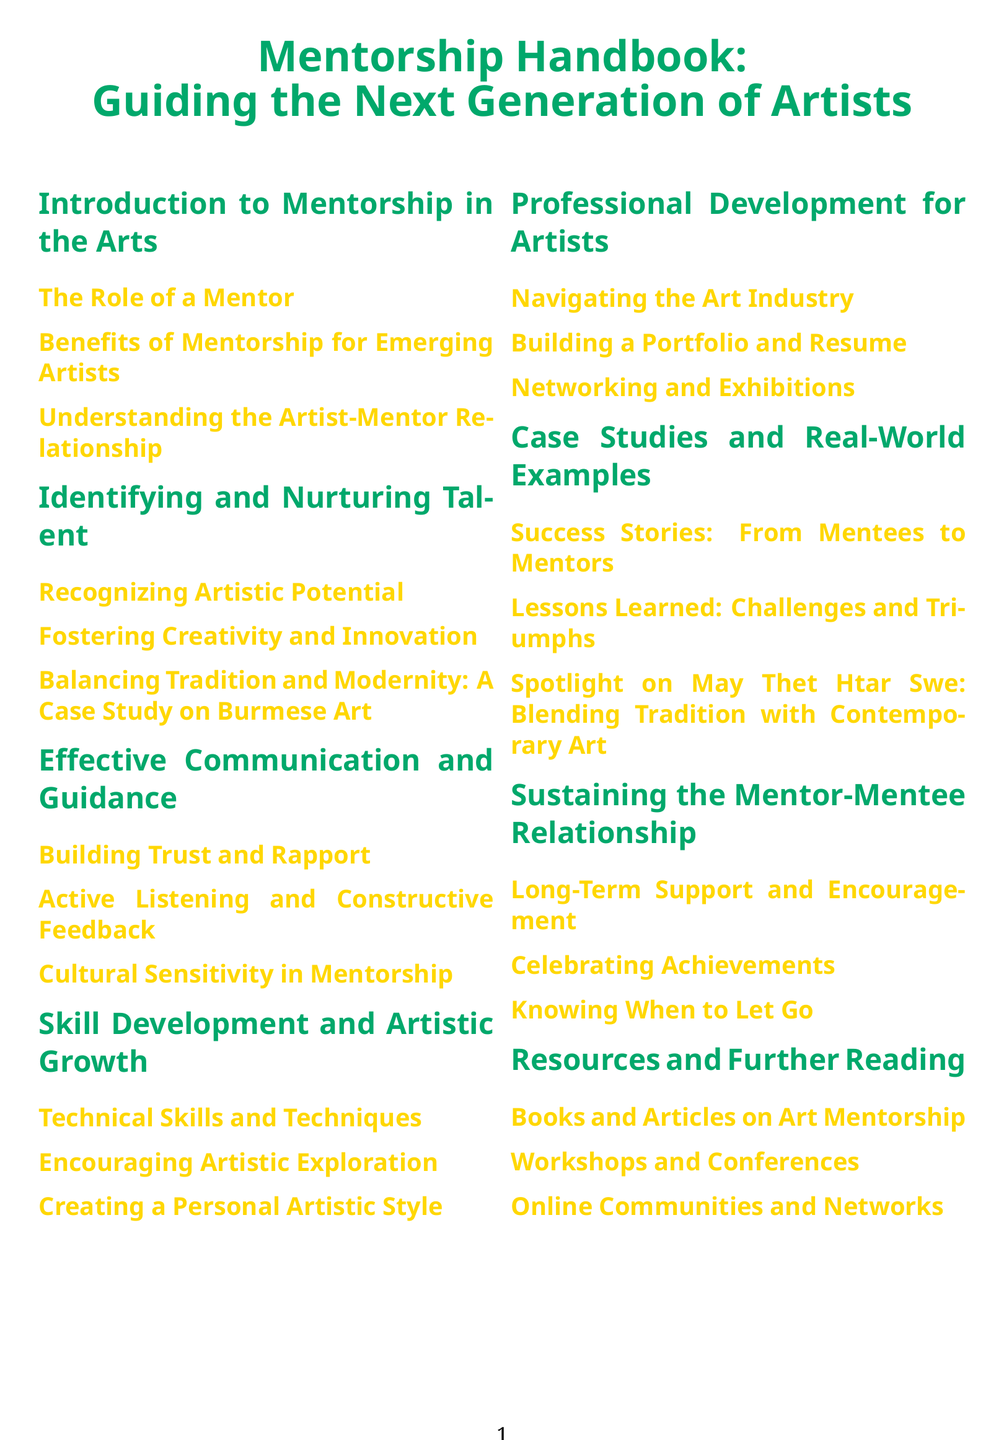what is the title of the handbook? The title of the handbook is the main heading found at the top of the document.
Answer: Mentorship Handbook: Guiding the Next Generation of Artists how many sections are in the document? The total number of sections has to be counted from the table of contents listed in the document.
Answer: 8 what is one of the case studies mentioned in the handbook? The specific case study is referenced in the section about case studies and real-world examples.
Answer: Spotlight on May Thet Htar Swe: Blending Tradition with Contemporary Art name a benefit of mentorship for emerging artists. This information can be found under the subsection related to benefits in the introduction section.
Answer: Benefits of Mentorship for Emerging Artists what is covered under skill development and artistic growth? This queries the subsection titles found in the corresponding section.
Answer: Technical Skills and Techniques how does the handbook suggest to build trust? This question refers to the guidance section, specifically the subsection titles related to communication and rapport.
Answer: Building Trust and Rapport which subsection discusses balancing tradition and modernity? This is directly found in the section about identifying and nurturing talent, asking for a specific topic.
Answer: Balancing Tradition and Modernity: A Case Study on Burmese Art what resources are suggested for further reading? This aims at a general category found under the resources section of the document.
Answer: Books and Articles on Art Mentorship 